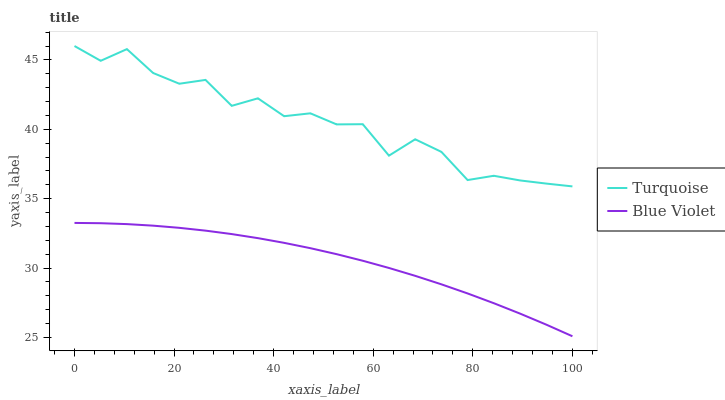Does Blue Violet have the maximum area under the curve?
Answer yes or no. No. Is Blue Violet the roughest?
Answer yes or no. No. Does Blue Violet have the highest value?
Answer yes or no. No. Is Blue Violet less than Turquoise?
Answer yes or no. Yes. Is Turquoise greater than Blue Violet?
Answer yes or no. Yes. Does Blue Violet intersect Turquoise?
Answer yes or no. No. 